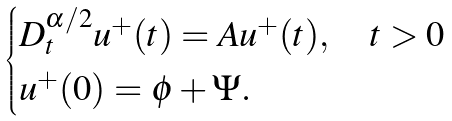<formula> <loc_0><loc_0><loc_500><loc_500>\begin{cases} D _ { t } ^ { \alpha / 2 } u ^ { + } ( t ) = A u ^ { + } ( t ) , \quad t > 0 \\ u ^ { + } ( 0 ) = \phi + \Psi . \end{cases}</formula> 